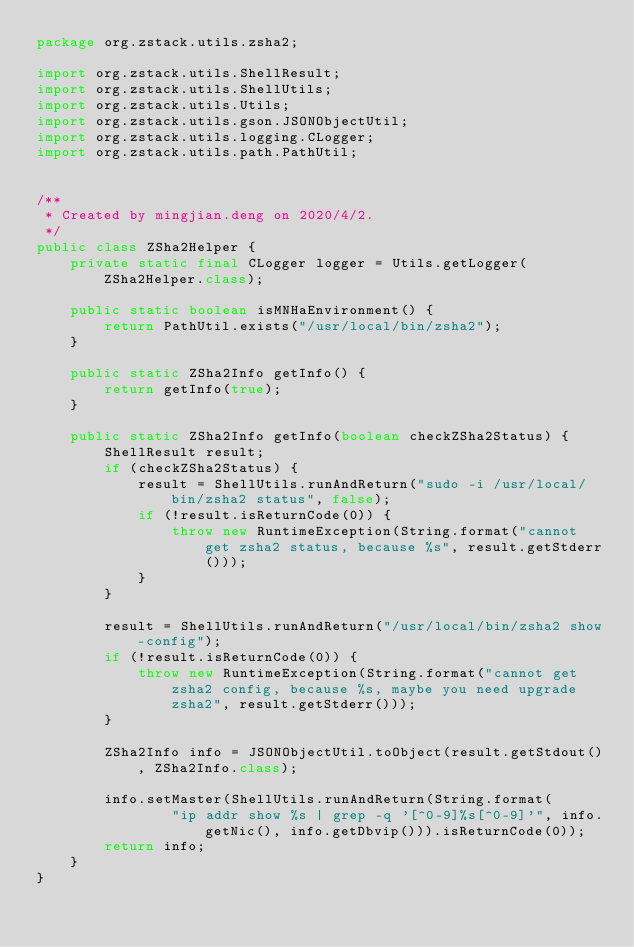<code> <loc_0><loc_0><loc_500><loc_500><_Java_>package org.zstack.utils.zsha2;

import org.zstack.utils.ShellResult;
import org.zstack.utils.ShellUtils;
import org.zstack.utils.Utils;
import org.zstack.utils.gson.JSONObjectUtil;
import org.zstack.utils.logging.CLogger;
import org.zstack.utils.path.PathUtil;


/**
 * Created by mingjian.deng on 2020/4/2.
 */
public class ZSha2Helper {
    private static final CLogger logger = Utils.getLogger(ZSha2Helper.class);

    public static boolean isMNHaEnvironment() {
        return PathUtil.exists("/usr/local/bin/zsha2");
    }

    public static ZSha2Info getInfo() {
        return getInfo(true);
    }

    public static ZSha2Info getInfo(boolean checkZSha2Status) {
        ShellResult result;
        if (checkZSha2Status) {
            result = ShellUtils.runAndReturn("sudo -i /usr/local/bin/zsha2 status", false);
            if (!result.isReturnCode(0)) {
                throw new RuntimeException(String.format("cannot get zsha2 status, because %s", result.getStderr()));
            }
        }

        result = ShellUtils.runAndReturn("/usr/local/bin/zsha2 show-config");
        if (!result.isReturnCode(0)) {
            throw new RuntimeException(String.format("cannot get zsha2 config, because %s, maybe you need upgrade zsha2", result.getStderr()));
        }

        ZSha2Info info = JSONObjectUtil.toObject(result.getStdout(), ZSha2Info.class);

        info.setMaster(ShellUtils.runAndReturn(String.format(
                "ip addr show %s | grep -q '[^0-9]%s[^0-9]'", info.getNic(), info.getDbvip())).isReturnCode(0));
        return info;
    }
}
</code> 